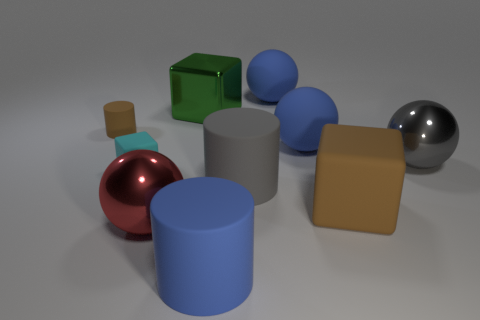Subtract all purple blocks. How many blue spheres are left? 2 Subtract all gray balls. How many balls are left? 3 Subtract 2 spheres. How many spheres are left? 2 Subtract all gray balls. How many balls are left? 3 Subtract all purple spheres. Subtract all green blocks. How many spheres are left? 4 Subtract all cubes. How many objects are left? 7 Add 4 green objects. How many green objects are left? 5 Add 6 big yellow rubber spheres. How many big yellow rubber spheres exist? 6 Subtract 1 green cubes. How many objects are left? 9 Subtract all big red rubber balls. Subtract all large blue things. How many objects are left? 7 